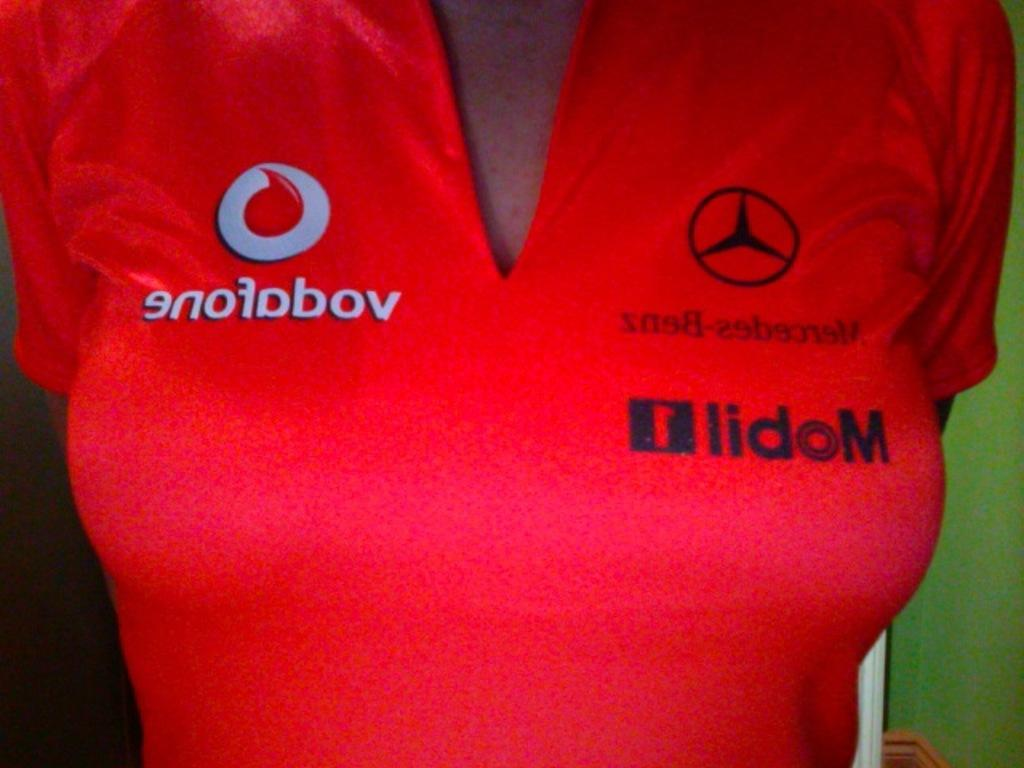<image>
Create a compact narrative representing the image presented. A woman is wearing a v neck top with formula one sponsors including Vodafone on it. 